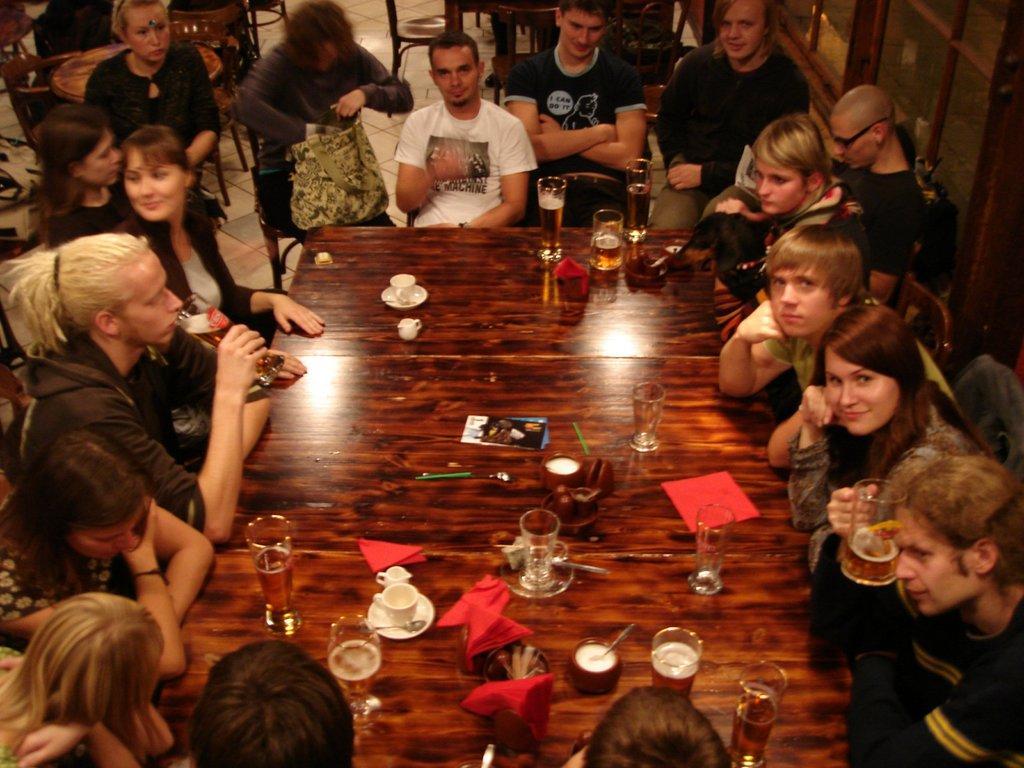In one or two sentences, can you explain what this image depicts? This picture is clicked inside the room. Here, we see many people sitting on chair. In front of them, we see a brown table on which cup, saucer, glass, jar, paper, tissue, spoon, pen, book are placed on it. Behind them, we see many tables and chairs. Man woman in the middle of the picture wearing grey jacket is holding bag in her hand. 